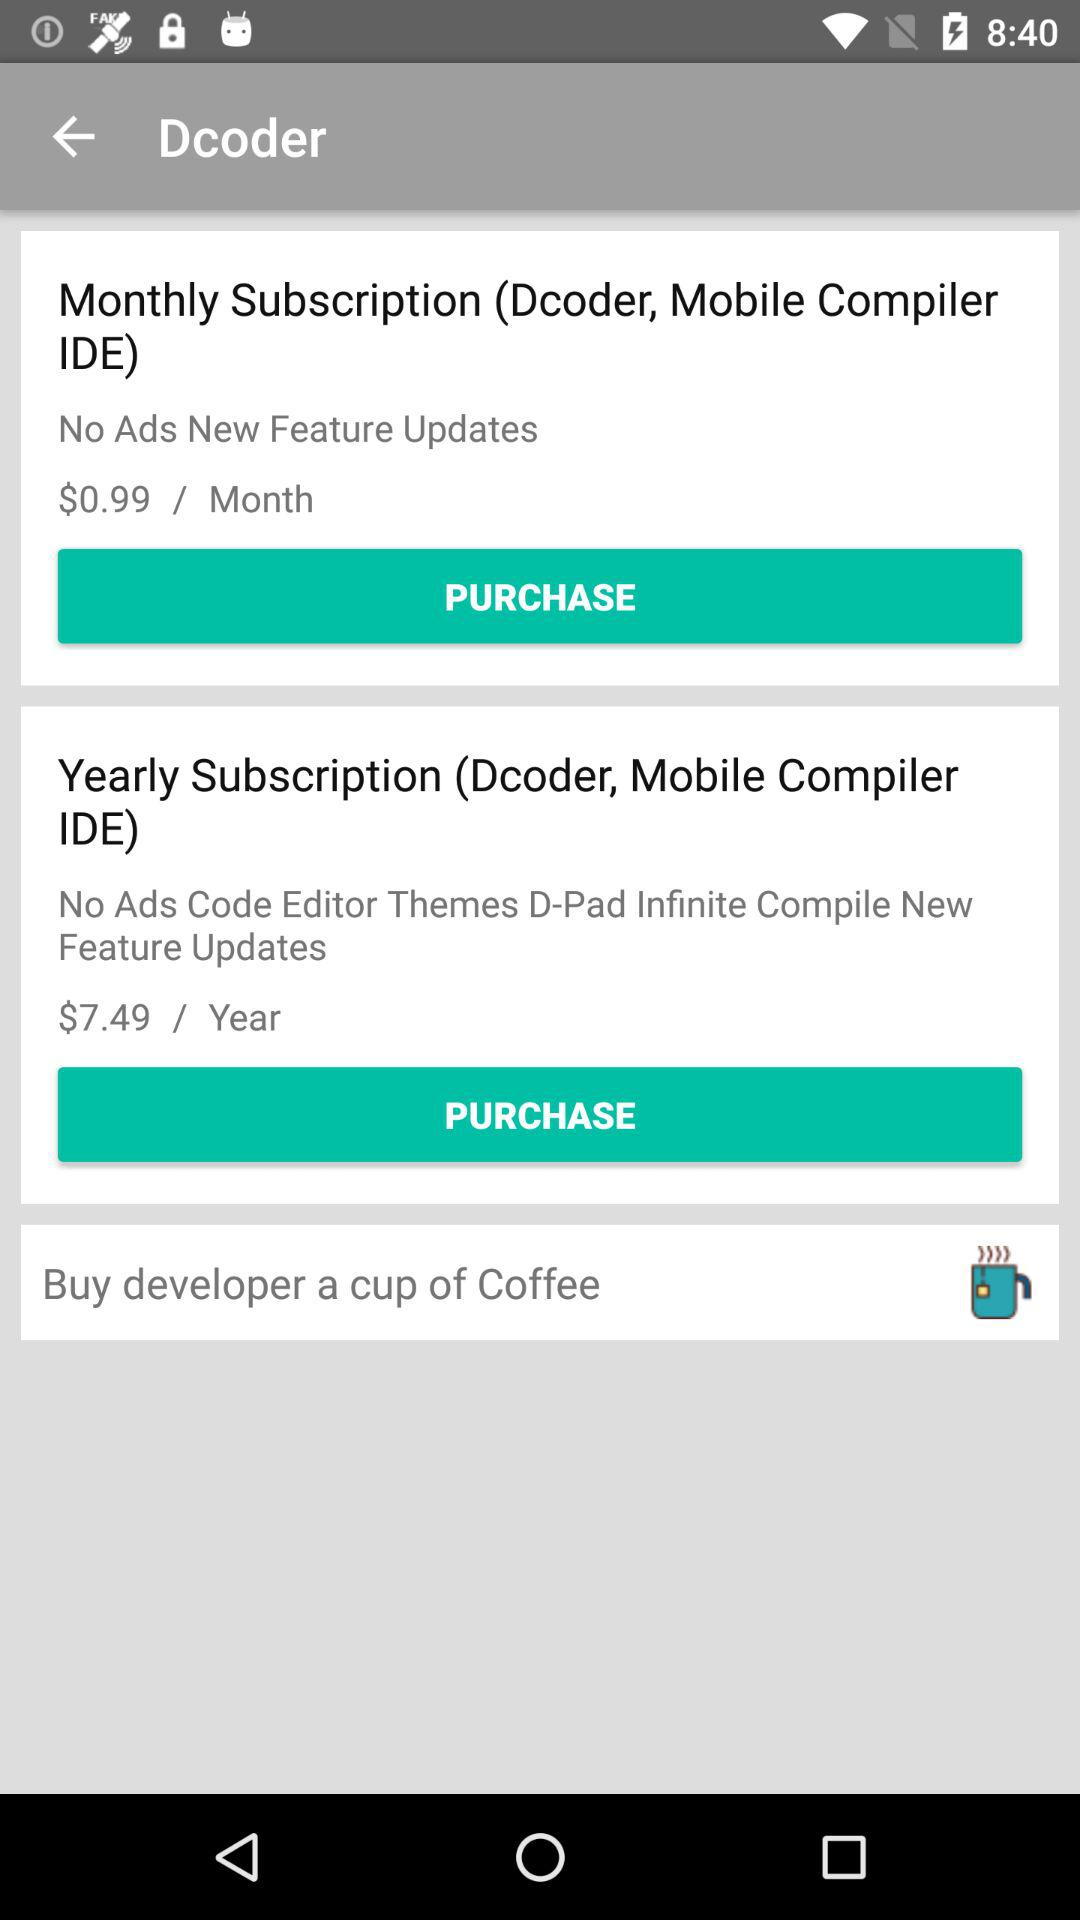What is the price of the "Yearly Subscription" package? The price is $7.49/year. 